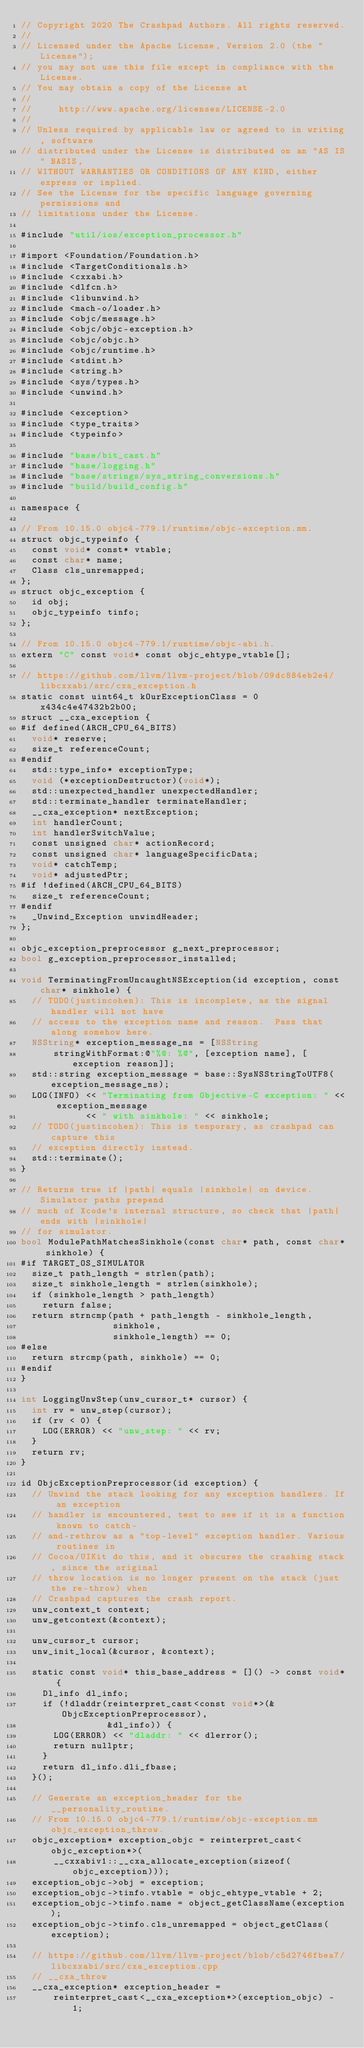Convert code to text. <code><loc_0><loc_0><loc_500><loc_500><_ObjectiveC_>// Copyright 2020 The Crashpad Authors. All rights reserved.
//
// Licensed under the Apache License, Version 2.0 (the "License");
// you may not use this file except in compliance with the License.
// You may obtain a copy of the License at
//
//     http://www.apache.org/licenses/LICENSE-2.0
//
// Unless required by applicable law or agreed to in writing, software
// distributed under the License is distributed on an "AS IS" BASIS,
// WITHOUT WARRANTIES OR CONDITIONS OF ANY KIND, either express or implied.
// See the License for the specific language governing permissions and
// limitations under the License.

#include "util/ios/exception_processor.h"

#import <Foundation/Foundation.h>
#include <TargetConditionals.h>
#include <cxxabi.h>
#include <dlfcn.h>
#include <libunwind.h>
#include <mach-o/loader.h>
#include <objc/message.h>
#include <objc/objc-exception.h>
#include <objc/objc.h>
#include <objc/runtime.h>
#include <stdint.h>
#include <string.h>
#include <sys/types.h>
#include <unwind.h>

#include <exception>
#include <type_traits>
#include <typeinfo>

#include "base/bit_cast.h"
#include "base/logging.h"
#include "base/strings/sys_string_conversions.h"
#include "build/build_config.h"

namespace {

// From 10.15.0 objc4-779.1/runtime/objc-exception.mm.
struct objc_typeinfo {
  const void* const* vtable;
  const char* name;
  Class cls_unremapped;
};
struct objc_exception {
  id obj;
  objc_typeinfo tinfo;
};

// From 10.15.0 objc4-779.1/runtime/objc-abi.h.
extern "C" const void* const objc_ehtype_vtable[];

// https://github.com/llvm/llvm-project/blob/09dc884eb2e4/libcxxabi/src/cxa_exception.h
static const uint64_t kOurExceptionClass = 0x434c4e47432b2b00;
struct __cxa_exception {
#if defined(ARCH_CPU_64_BITS)
  void* reserve;
  size_t referenceCount;
#endif
  std::type_info* exceptionType;
  void (*exceptionDestructor)(void*);
  std::unexpected_handler unexpectedHandler;
  std::terminate_handler terminateHandler;
  __cxa_exception* nextException;
  int handlerCount;
  int handlerSwitchValue;
  const unsigned char* actionRecord;
  const unsigned char* languageSpecificData;
  void* catchTemp;
  void* adjustedPtr;
#if !defined(ARCH_CPU_64_BITS)
  size_t referenceCount;
#endif
  _Unwind_Exception unwindHeader;
};

objc_exception_preprocessor g_next_preprocessor;
bool g_exception_preprocessor_installed;

void TerminatingFromUncaughtNSException(id exception, const char* sinkhole) {
  // TODO(justincohen): This is incomplete, as the signal handler will not have
  // access to the exception name and reason.  Pass that along somehow here.
  NSString* exception_message_ns = [NSString
      stringWithFormat:@"%@: %@", [exception name], [exception reason]];
  std::string exception_message = base::SysNSStringToUTF8(exception_message_ns);
  LOG(INFO) << "Terminating from Objective-C exception: " << exception_message
            << " with sinkhole: " << sinkhole;
  // TODO(justincohen): This is temporary, as crashpad can capture this
  // exception directly instead.
  std::terminate();
}

// Returns true if |path| equals |sinkhole| on device. Simulator paths prepend
// much of Xcode's internal structure, so check that |path| ends with |sinkhole|
// for simulator.
bool ModulePathMatchesSinkhole(const char* path, const char* sinkhole) {
#if TARGET_OS_SIMULATOR
  size_t path_length = strlen(path);
  size_t sinkhole_length = strlen(sinkhole);
  if (sinkhole_length > path_length)
    return false;
  return strncmp(path + path_length - sinkhole_length,
                 sinkhole,
                 sinkhole_length) == 0;
#else
  return strcmp(path, sinkhole) == 0;
#endif
}

int LoggingUnwStep(unw_cursor_t* cursor) {
  int rv = unw_step(cursor);
  if (rv < 0) {
    LOG(ERROR) << "unw_step: " << rv;
  }
  return rv;
}

id ObjcExceptionPreprocessor(id exception) {
  // Unwind the stack looking for any exception handlers. If an exception
  // handler is encountered, test to see if it is a function known to catch-
  // and-rethrow as a "top-level" exception handler. Various routines in
  // Cocoa/UIKit do this, and it obscures the crashing stack, since the original
  // throw location is no longer present on the stack (just the re-throw) when
  // Crashpad captures the crash report.
  unw_context_t context;
  unw_getcontext(&context);

  unw_cursor_t cursor;
  unw_init_local(&cursor, &context);

  static const void* this_base_address = []() -> const void* {
    Dl_info dl_info;
    if (!dladdr(reinterpret_cast<const void*>(&ObjcExceptionPreprocessor),
                &dl_info)) {
      LOG(ERROR) << "dladdr: " << dlerror();
      return nullptr;
    }
    return dl_info.dli_fbase;
  }();

  // Generate an exception_header for the __personality_routine.
  // From 10.15.0 objc4-779.1/runtime/objc-exception.mm objc_exception_throw.
  objc_exception* exception_objc = reinterpret_cast<objc_exception*>(
      __cxxabiv1::__cxa_allocate_exception(sizeof(objc_exception)));
  exception_objc->obj = exception;
  exception_objc->tinfo.vtable = objc_ehtype_vtable + 2;
  exception_objc->tinfo.name = object_getClassName(exception);
  exception_objc->tinfo.cls_unremapped = object_getClass(exception);

  // https://github.com/llvm/llvm-project/blob/c5d2746fbea7/libcxxabi/src/cxa_exception.cpp
  // __cxa_throw
  __cxa_exception* exception_header =
      reinterpret_cast<__cxa_exception*>(exception_objc) - 1;</code> 